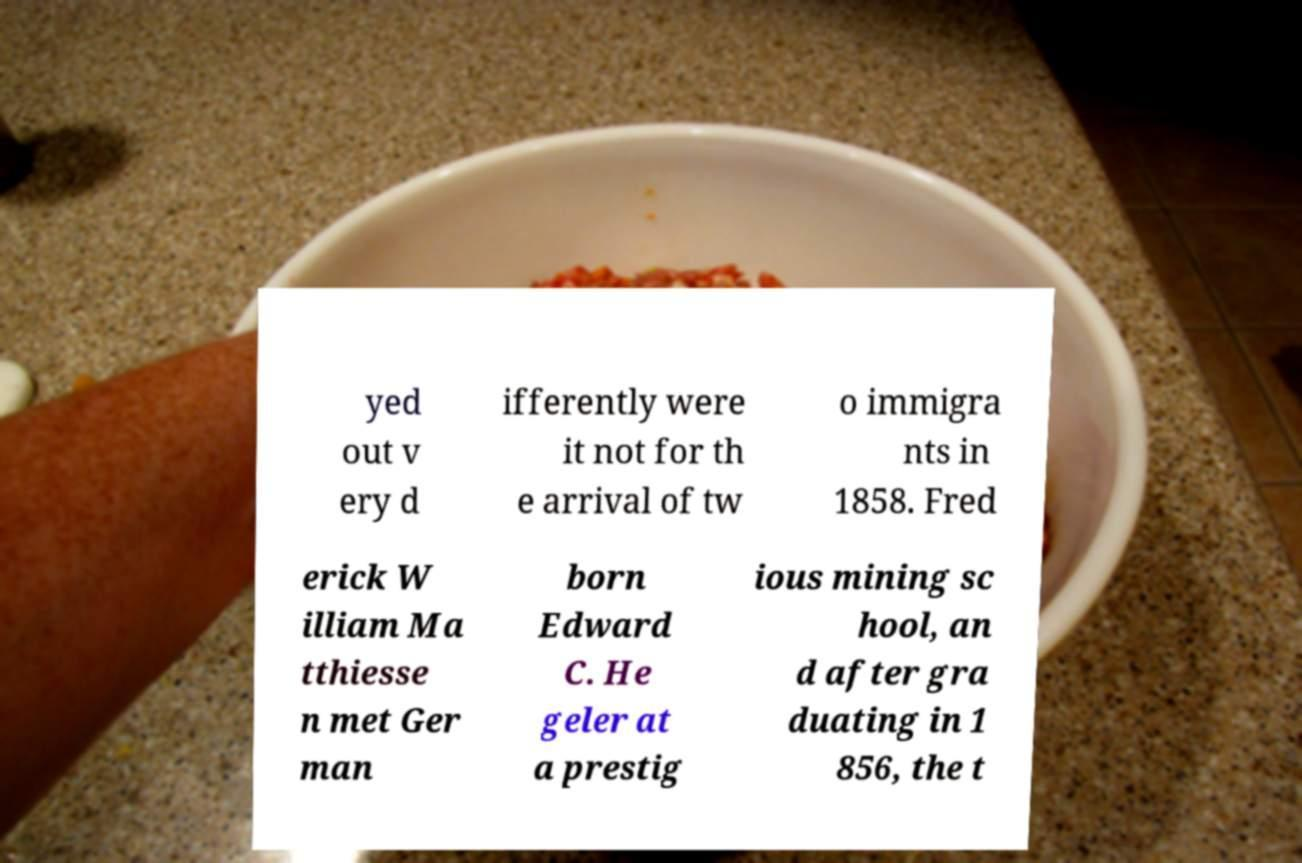Please read and relay the text visible in this image. What does it say? yed out v ery d ifferently were it not for th e arrival of tw o immigra nts in 1858. Fred erick W illiam Ma tthiesse n met Ger man born Edward C. He geler at a prestig ious mining sc hool, an d after gra duating in 1 856, the t 